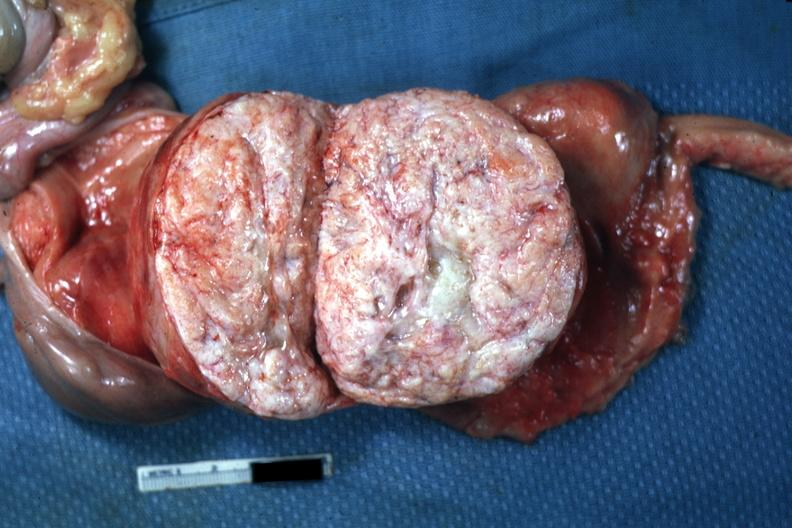s myoma lesion quite typical close-up photo?
Answer the question using a single word or phrase. Yes 